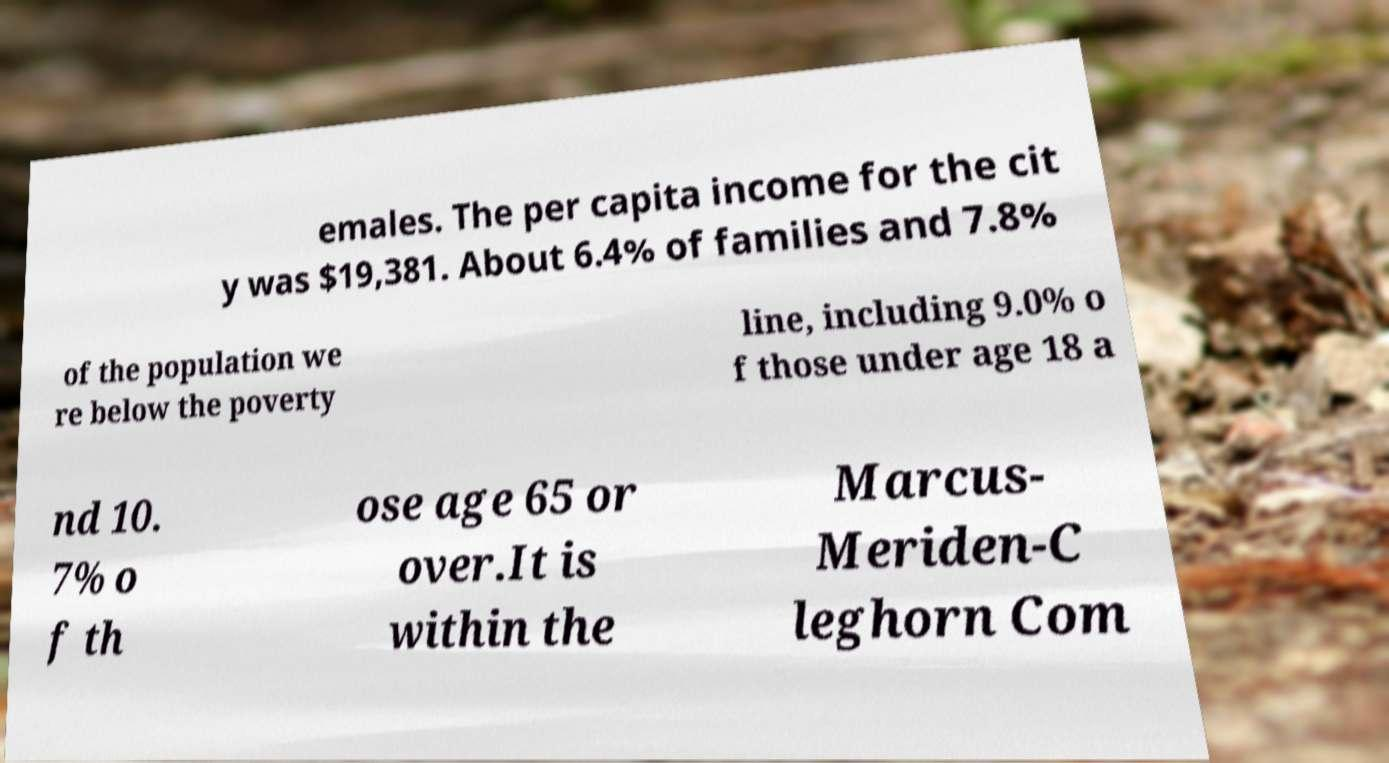What messages or text are displayed in this image? I need them in a readable, typed format. emales. The per capita income for the cit y was $19,381. About 6.4% of families and 7.8% of the population we re below the poverty line, including 9.0% o f those under age 18 a nd 10. 7% o f th ose age 65 or over.It is within the Marcus- Meriden-C leghorn Com 